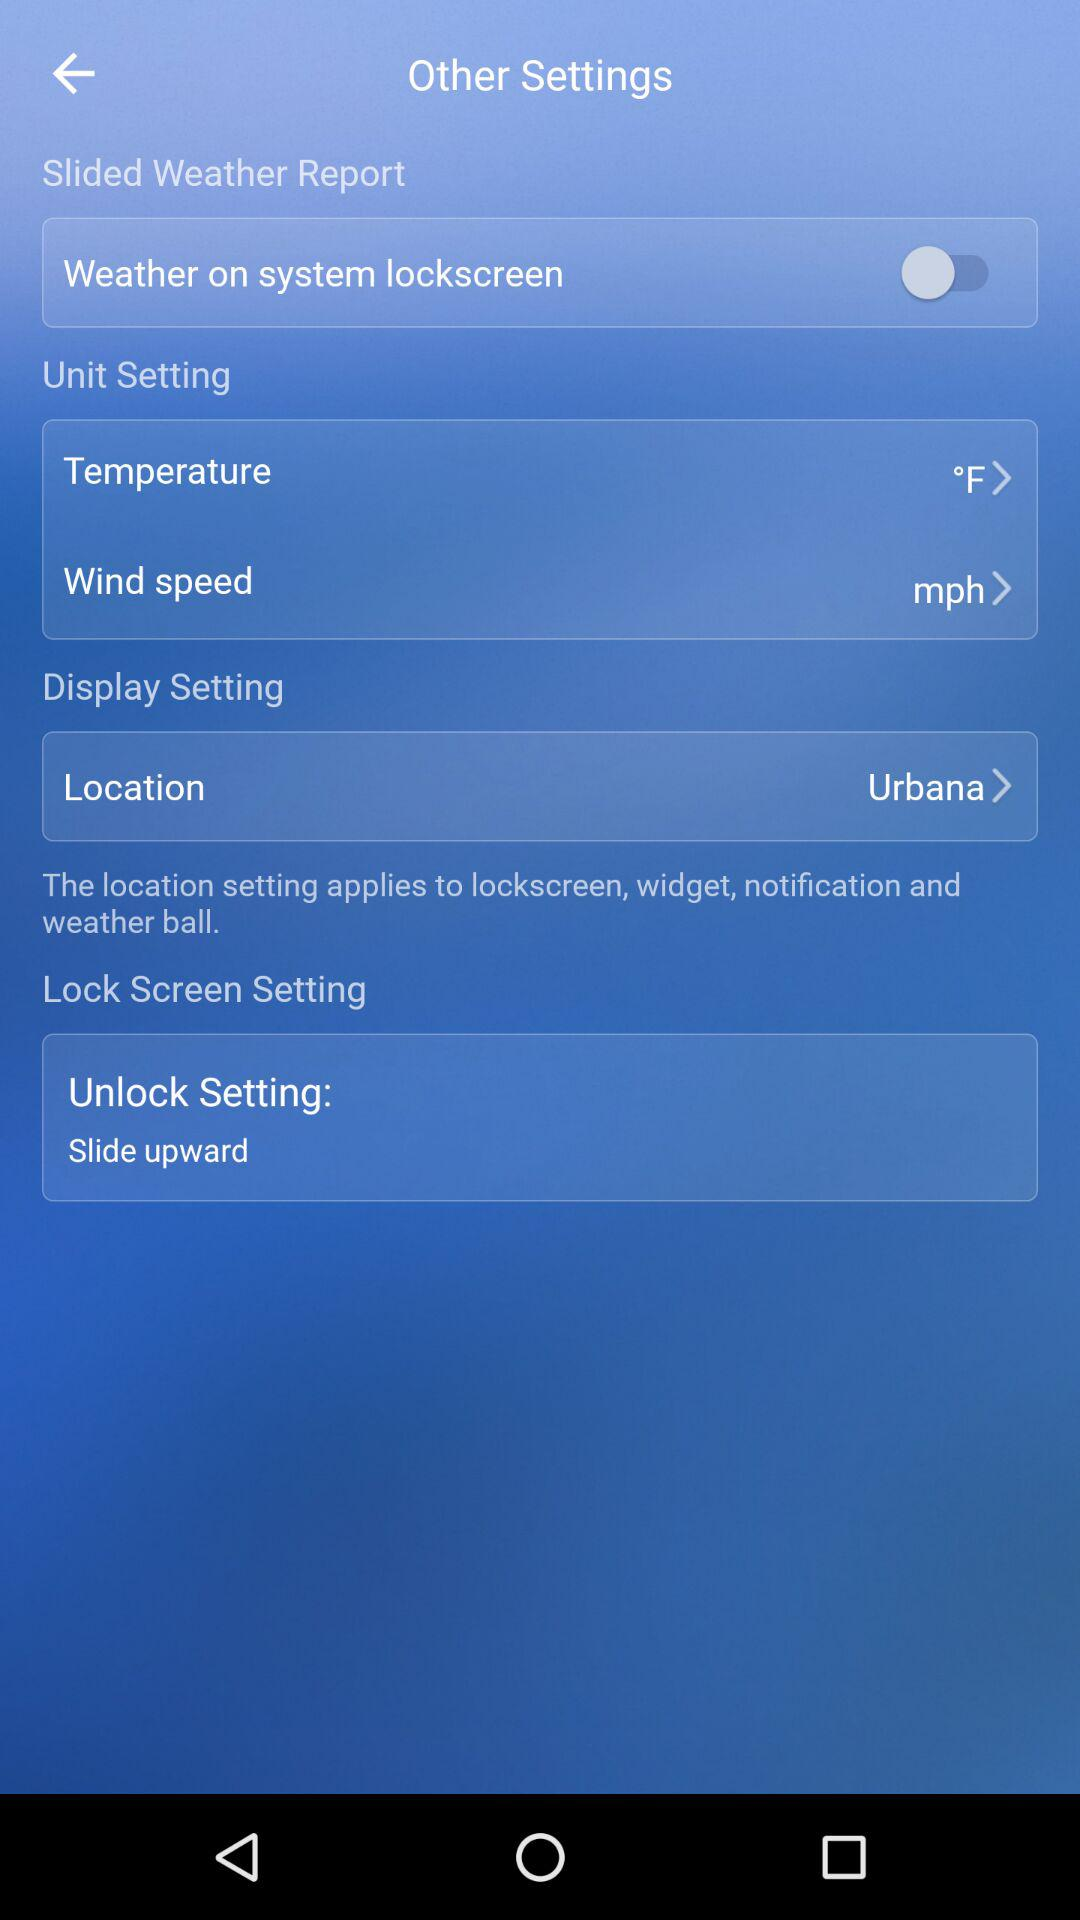What is the unit of wind speed measurement? The unit of wind speed measurement is mph. 